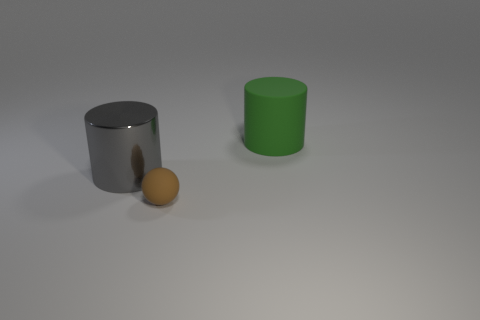What number of objects are either matte things that are behind the tiny brown matte sphere or tiny matte things?
Keep it short and to the point. 2. How many rubber things are on the right side of the matte object that is behind the big metal object?
Your response must be concise. 0. Is the number of large cylinders in front of the small thing less than the number of large objects that are on the right side of the large gray metal cylinder?
Provide a short and direct response. Yes. There is a big object that is in front of the matte object that is behind the small brown rubber ball; what is its shape?
Offer a terse response. Cylinder. What number of other things are there of the same material as the green cylinder
Provide a short and direct response. 1. Is there anything else that is the same size as the rubber sphere?
Your answer should be very brief. No. Are there more tiny blue cubes than big green matte cylinders?
Your answer should be very brief. No. There is a cylinder behind the gray metallic thing that is on the left side of the object that is right of the matte sphere; what is its size?
Ensure brevity in your answer.  Large. Do the brown rubber sphere and the object behind the metal object have the same size?
Provide a succinct answer. No. Is the number of gray cylinders behind the large green rubber object less than the number of balls?
Offer a very short reply. Yes. 